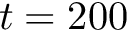Convert formula to latex. <formula><loc_0><loc_0><loc_500><loc_500>t = 2 0 0</formula> 